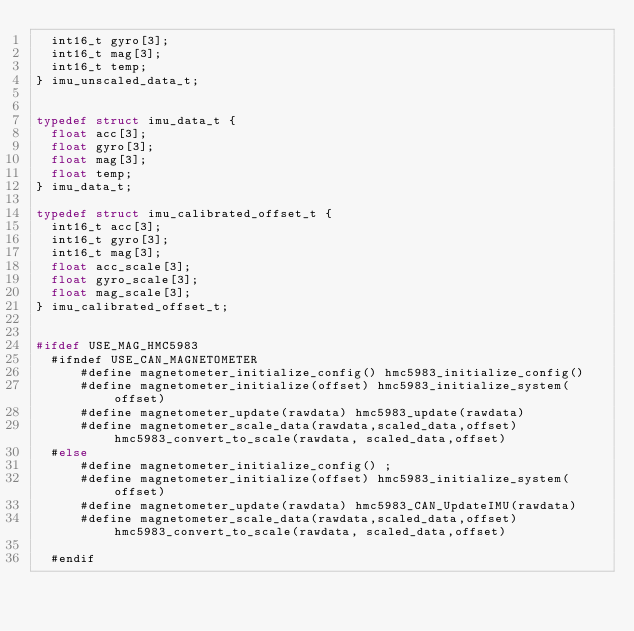Convert code to text. <code><loc_0><loc_0><loc_500><loc_500><_C_>	int16_t gyro[3];
	int16_t mag[3];
	int16_t temp;
} imu_unscaled_data_t;


typedef struct imu_data_t {
	float acc[3];
	float gyro[3];
	float mag[3];
	float temp;
} imu_data_t;

typedef struct imu_calibrated_offset_t {
	int16_t acc[3];
	int16_t gyro[3];
	int16_t mag[3];
	float acc_scale[3];
	float gyro_scale[3];
	float mag_scale[3];
} imu_calibrated_offset_t;


#ifdef USE_MAG_HMC5983
	#ifndef USE_CAN_MAGNETOMETER
			#define magnetometer_initialize_config() hmc5983_initialize_config()
			#define magnetometer_initialize(offset) hmc5983_initialize_system(offset)
			#define magnetometer_update(rawdata) hmc5983_update(rawdata)
			#define magnetometer_scale_data(rawdata,scaled_data,offset) hmc5983_convert_to_scale(rawdata, scaled_data,offset)
	#else
			#define magnetometer_initialize_config() ;
			#define magnetometer_initialize(offset) hmc5983_initialize_system(offset)
			#define magnetometer_update(rawdata) hmc5983_CAN_UpdateIMU(rawdata)
			#define magnetometer_scale_data(rawdata,scaled_data,offset) hmc5983_convert_to_scale(rawdata, scaled_data,offset)
	
	#endif</code> 